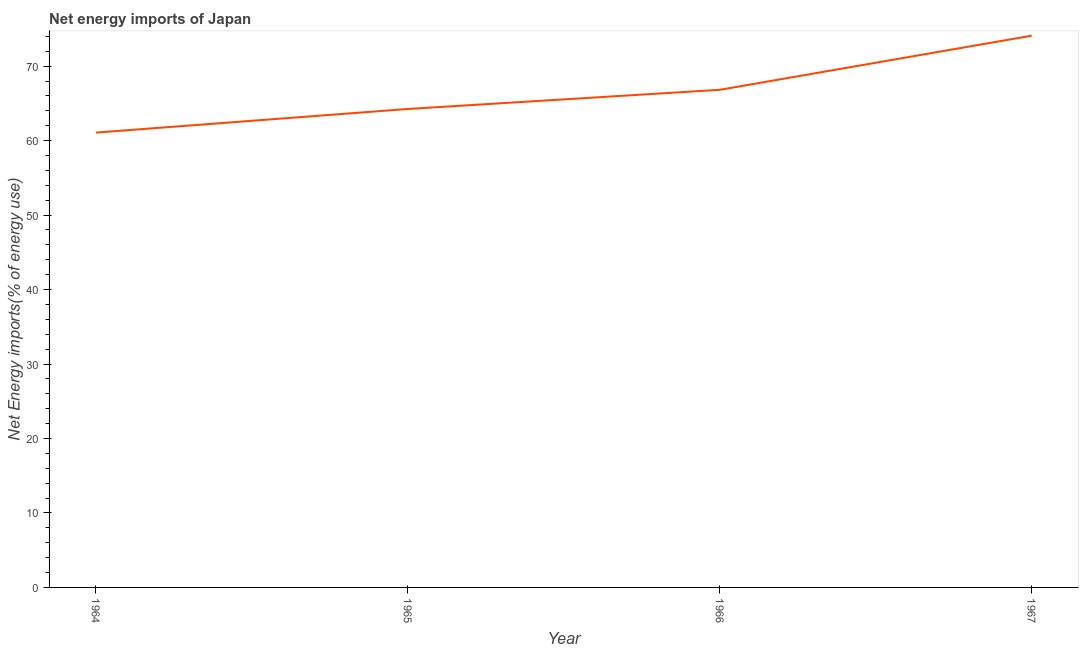What is the energy imports in 1965?
Offer a very short reply. 64.25. Across all years, what is the maximum energy imports?
Provide a short and direct response. 74.09. Across all years, what is the minimum energy imports?
Provide a short and direct response. 61.07. In which year was the energy imports maximum?
Keep it short and to the point. 1967. In which year was the energy imports minimum?
Make the answer very short. 1964. What is the sum of the energy imports?
Ensure brevity in your answer.  266.23. What is the difference between the energy imports in 1965 and 1966?
Your response must be concise. -2.57. What is the average energy imports per year?
Your answer should be very brief. 66.56. What is the median energy imports?
Your response must be concise. 65.53. Do a majority of the years between 1967 and 1964 (inclusive) have energy imports greater than 26 %?
Give a very brief answer. Yes. What is the ratio of the energy imports in 1965 to that in 1966?
Keep it short and to the point. 0.96. Is the energy imports in 1966 less than that in 1967?
Make the answer very short. Yes. Is the difference between the energy imports in 1966 and 1967 greater than the difference between any two years?
Your response must be concise. No. What is the difference between the highest and the second highest energy imports?
Your answer should be compact. 7.27. Is the sum of the energy imports in 1965 and 1966 greater than the maximum energy imports across all years?
Your answer should be very brief. Yes. What is the difference between the highest and the lowest energy imports?
Your response must be concise. 13.01. How many years are there in the graph?
Offer a terse response. 4. Are the values on the major ticks of Y-axis written in scientific E-notation?
Keep it short and to the point. No. What is the title of the graph?
Your answer should be compact. Net energy imports of Japan. What is the label or title of the Y-axis?
Make the answer very short. Net Energy imports(% of energy use). What is the Net Energy imports(% of energy use) in 1964?
Offer a very short reply. 61.07. What is the Net Energy imports(% of energy use) in 1965?
Your answer should be compact. 64.25. What is the Net Energy imports(% of energy use) in 1966?
Offer a very short reply. 66.82. What is the Net Energy imports(% of energy use) in 1967?
Offer a terse response. 74.09. What is the difference between the Net Energy imports(% of energy use) in 1964 and 1965?
Give a very brief answer. -3.17. What is the difference between the Net Energy imports(% of energy use) in 1964 and 1966?
Your response must be concise. -5.74. What is the difference between the Net Energy imports(% of energy use) in 1964 and 1967?
Provide a short and direct response. -13.01. What is the difference between the Net Energy imports(% of energy use) in 1965 and 1966?
Keep it short and to the point. -2.57. What is the difference between the Net Energy imports(% of energy use) in 1965 and 1967?
Your answer should be very brief. -9.84. What is the difference between the Net Energy imports(% of energy use) in 1966 and 1967?
Offer a very short reply. -7.27. What is the ratio of the Net Energy imports(% of energy use) in 1964 to that in 1965?
Keep it short and to the point. 0.95. What is the ratio of the Net Energy imports(% of energy use) in 1964 to that in 1966?
Offer a very short reply. 0.91. What is the ratio of the Net Energy imports(% of energy use) in 1964 to that in 1967?
Give a very brief answer. 0.82. What is the ratio of the Net Energy imports(% of energy use) in 1965 to that in 1966?
Keep it short and to the point. 0.96. What is the ratio of the Net Energy imports(% of energy use) in 1965 to that in 1967?
Keep it short and to the point. 0.87. What is the ratio of the Net Energy imports(% of energy use) in 1966 to that in 1967?
Keep it short and to the point. 0.9. 